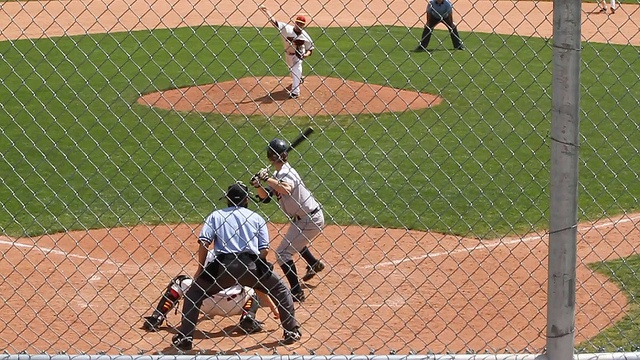Describe the objects in this image and their specific colors. I can see people in olive, black, lavender, gray, and darkgray tones, people in olive, gray, black, and lightgray tones, people in olive, black, maroon, gray, and darkgray tones, people in olive, lightgray, darkgray, and gray tones, and people in olive, black, gray, darkblue, and maroon tones in this image. 